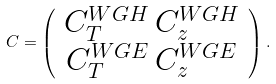<formula> <loc_0><loc_0><loc_500><loc_500>C = \left ( \begin{array} { c } C _ { T } ^ { W G H } \, C _ { z } ^ { W G H } \\ C _ { T } ^ { W G E } \, C _ { z } ^ { W G E } \end{array} \right ) .</formula> 